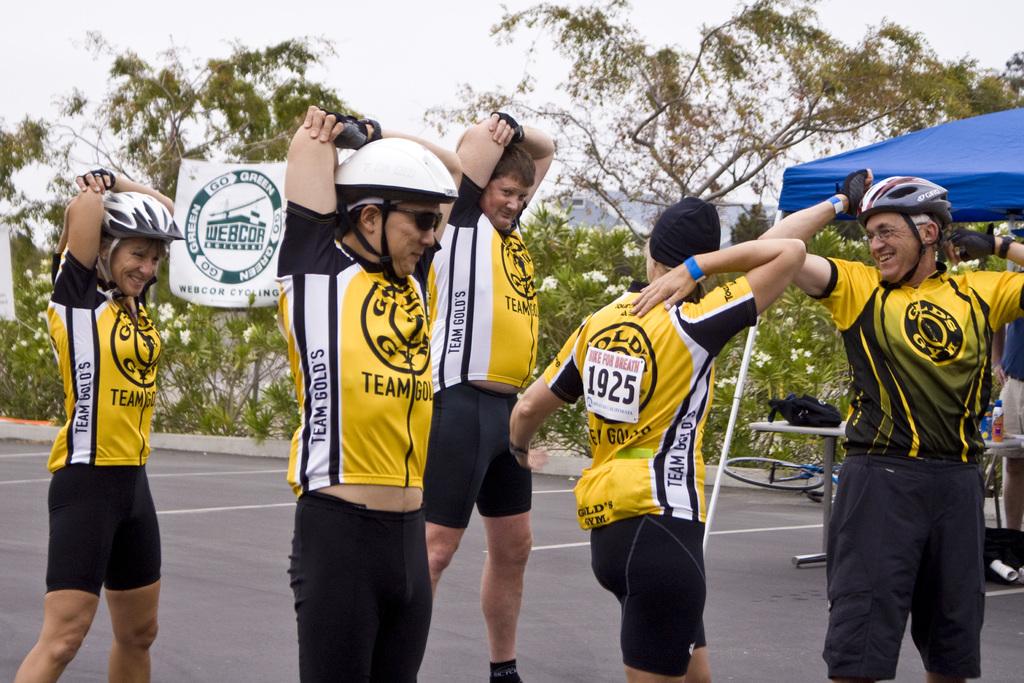What gym company sponsors these athletes?
Your answer should be compact. Gold's gym. What is the number on the back of the runner facing away?
Your answer should be very brief. 1925. 